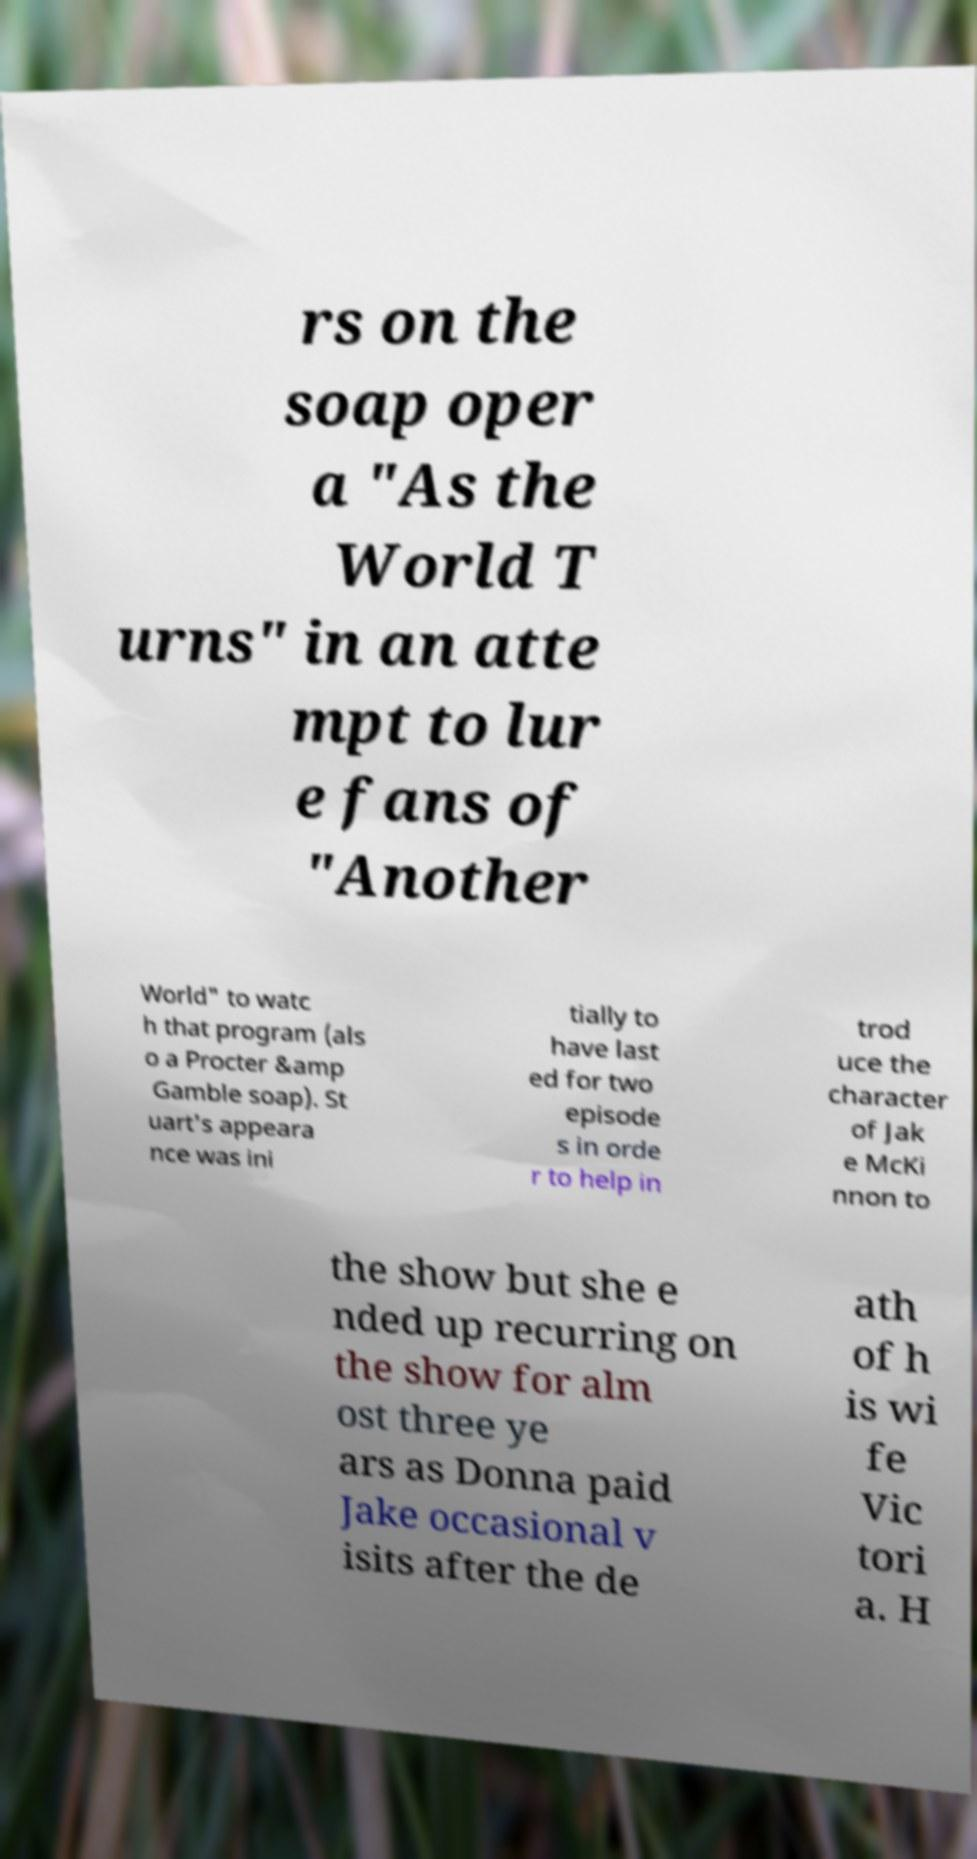Can you read and provide the text displayed in the image?This photo seems to have some interesting text. Can you extract and type it out for me? rs on the soap oper a "As the World T urns" in an atte mpt to lur e fans of "Another World" to watc h that program (als o a Procter &amp Gamble soap). St uart's appeara nce was ini tially to have last ed for two episode s in orde r to help in trod uce the character of Jak e McKi nnon to the show but she e nded up recurring on the show for alm ost three ye ars as Donna paid Jake occasional v isits after the de ath of h is wi fe Vic tori a. H 